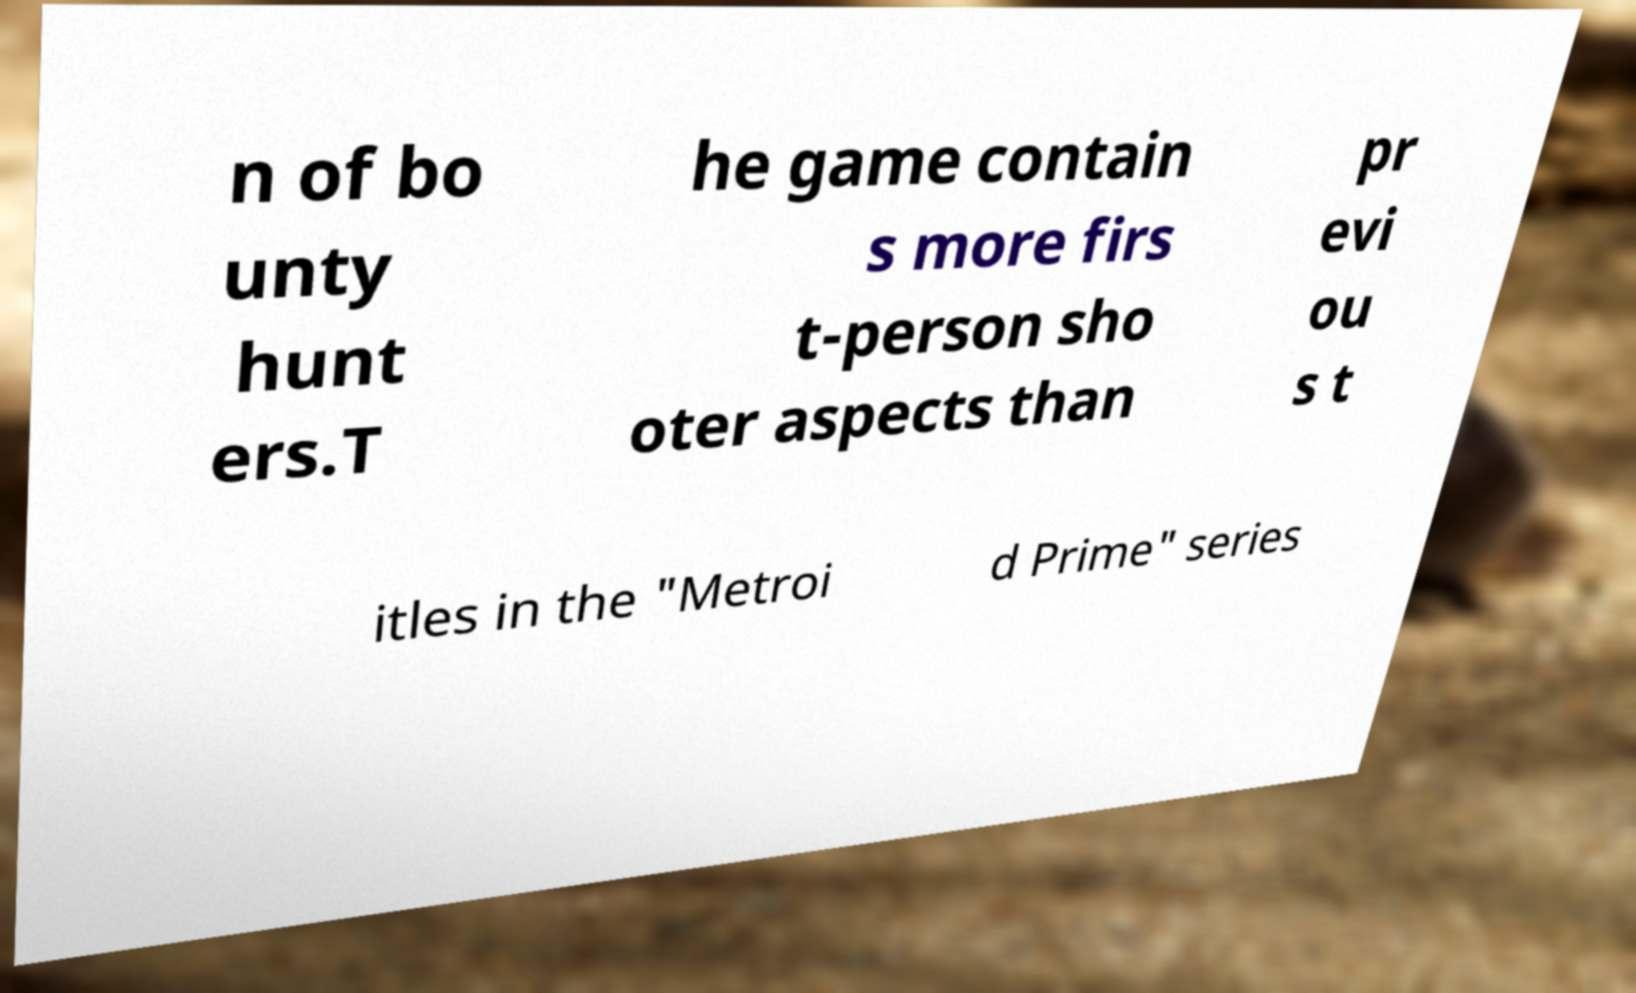Can you accurately transcribe the text from the provided image for me? n of bo unty hunt ers.T he game contain s more firs t-person sho oter aspects than pr evi ou s t itles in the "Metroi d Prime" series 